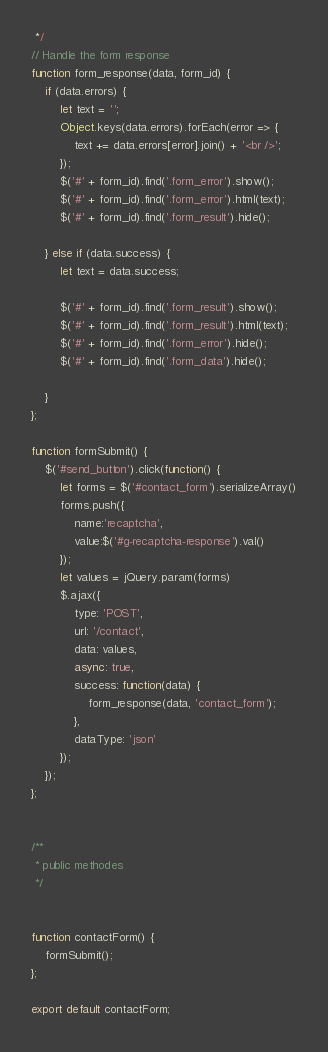<code> <loc_0><loc_0><loc_500><loc_500><_JavaScript_> */
// Handle the form response
function form_response(data, form_id) {
    if (data.errors) {
        let text = '';
        Object.keys(data.errors).forEach(error => {
            text += data.errors[error].join() + '<br />';
        });
        $('#' + form_id).find('.form_error').show();
        $('#' + form_id).find('.form_error').html(text);
        $('#' + form_id).find('.form_result').hide();

    } else if (data.success) {
        let text = data.success;

        $('#' + form_id).find('.form_result').show();
        $('#' + form_id).find('.form_result').html(text);
        $('#' + form_id).find('.form_error').hide();
        $('#' + form_id).find('.form_data').hide();

    }
};

function formSubmit() {
    $('#send_button').click(function() {
        let forms = $('#contact_form').serializeArray()
        forms.push({
            name:'recaptcha',
            value:$('#g-recaptcha-response').val()
        });
        let values = jQuery.param(forms)
        $.ajax({
            type: 'POST',
            url: '/contact',
            data: values,
            async: true,
            success: function(data) {
                form_response(data, 'contact_form');
            },
            dataType: 'json'
        });
    });
};


/**
 * public methodes
 */


function contactForm() {
    formSubmit();
};

export default contactForm;
</code> 